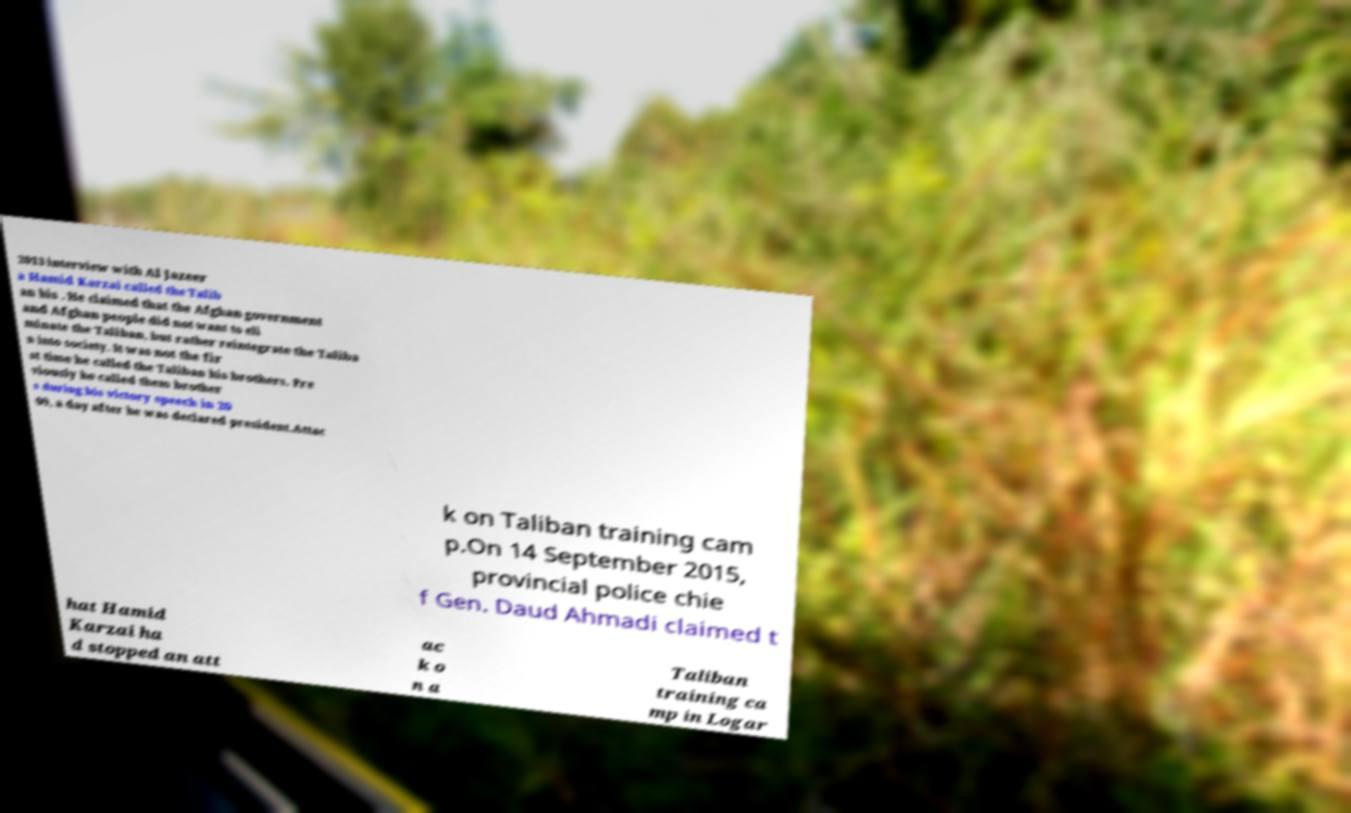Please identify and transcribe the text found in this image. 2013 interview with Al Jazeer a Hamid Karzai called the Talib an his . He claimed that the Afghan government and Afghan people did not want to eli minate the Taliban, but rather reintegrate the Taliba n into society. It was not the fir st time he called the Taliban his brothers. Pre viously he called them brother s during his victory speech in 20 09, a day after he was declared president.Attac k on Taliban training cam p.On 14 September 2015, provincial police chie f Gen. Daud Ahmadi claimed t hat Hamid Karzai ha d stopped an att ac k o n a Taliban training ca mp in Logar 